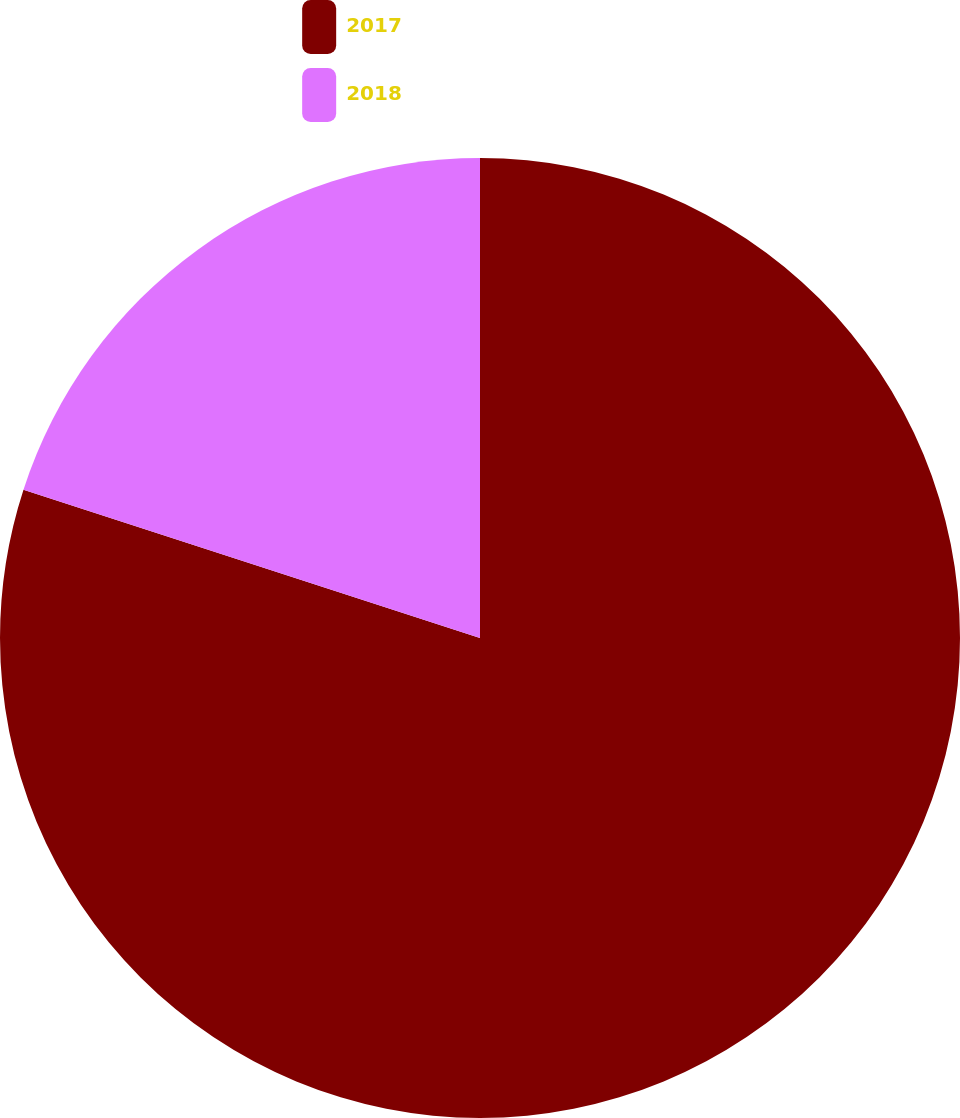<chart> <loc_0><loc_0><loc_500><loc_500><pie_chart><fcel>2017<fcel>2018<nl><fcel>80.0%<fcel>20.0%<nl></chart> 